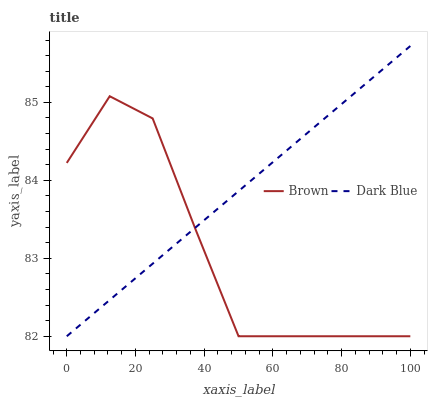Does Dark Blue have the minimum area under the curve?
Answer yes or no. No. Is Dark Blue the roughest?
Answer yes or no. No. 